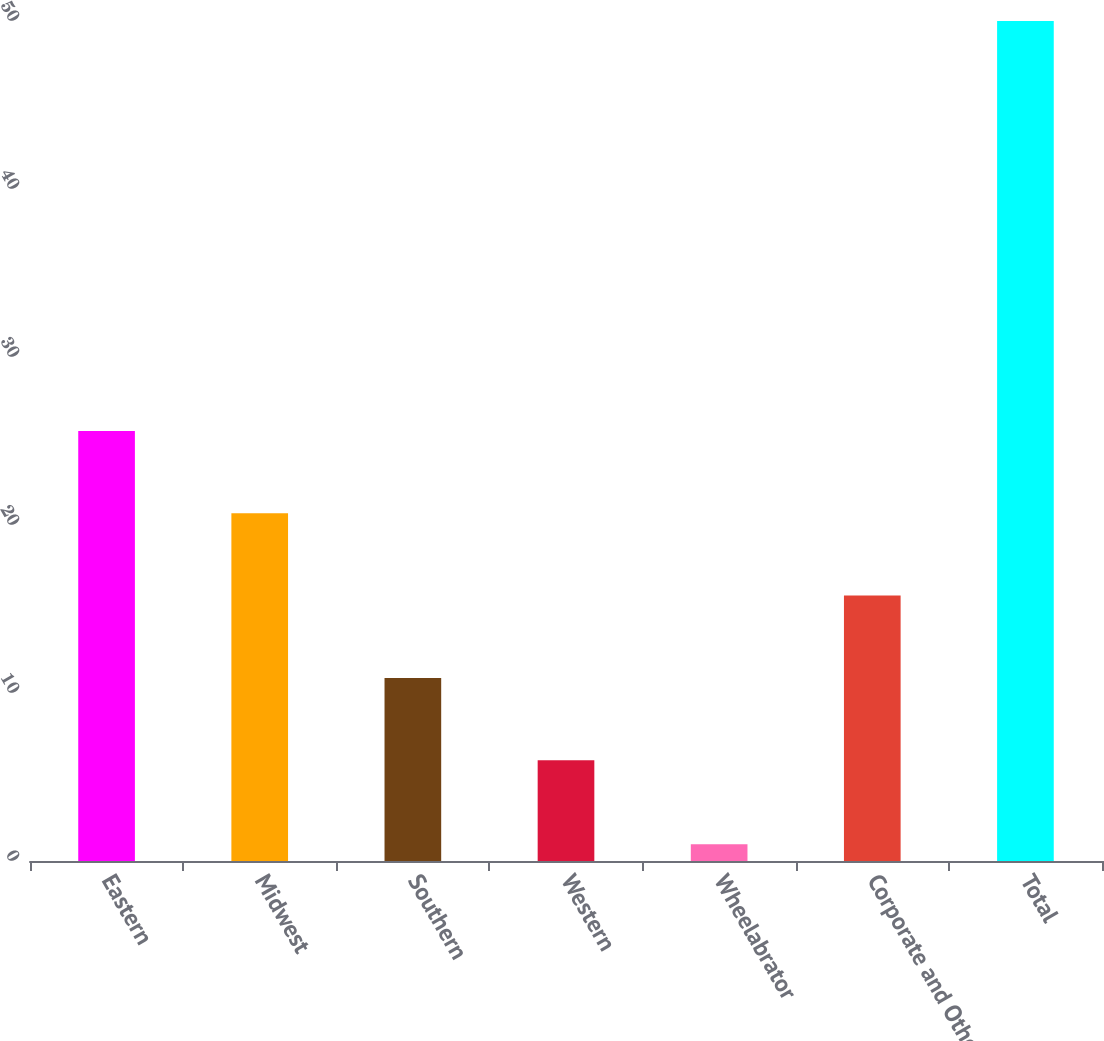<chart> <loc_0><loc_0><loc_500><loc_500><bar_chart><fcel>Eastern<fcel>Midwest<fcel>Southern<fcel>Western<fcel>Wheelabrator<fcel>Corporate and Other<fcel>Total<nl><fcel>25.6<fcel>20.7<fcel>10.9<fcel>6<fcel>1<fcel>15.8<fcel>50<nl></chart> 